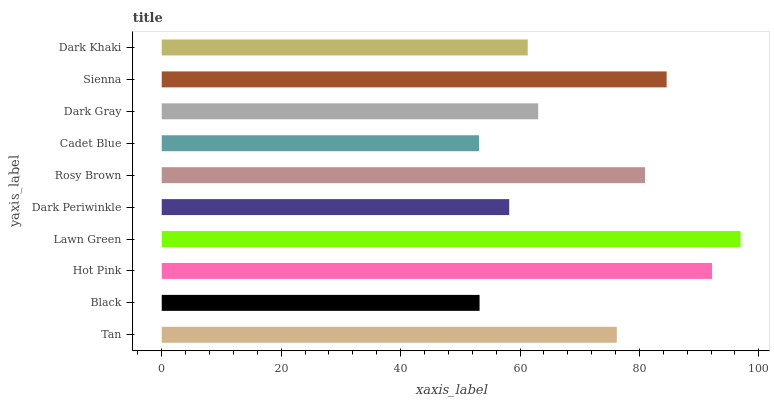Is Cadet Blue the minimum?
Answer yes or no. Yes. Is Lawn Green the maximum?
Answer yes or no. Yes. Is Black the minimum?
Answer yes or no. No. Is Black the maximum?
Answer yes or no. No. Is Tan greater than Black?
Answer yes or no. Yes. Is Black less than Tan?
Answer yes or no. Yes. Is Black greater than Tan?
Answer yes or no. No. Is Tan less than Black?
Answer yes or no. No. Is Tan the high median?
Answer yes or no. Yes. Is Dark Gray the low median?
Answer yes or no. Yes. Is Hot Pink the high median?
Answer yes or no. No. Is Dark Periwinkle the low median?
Answer yes or no. No. 